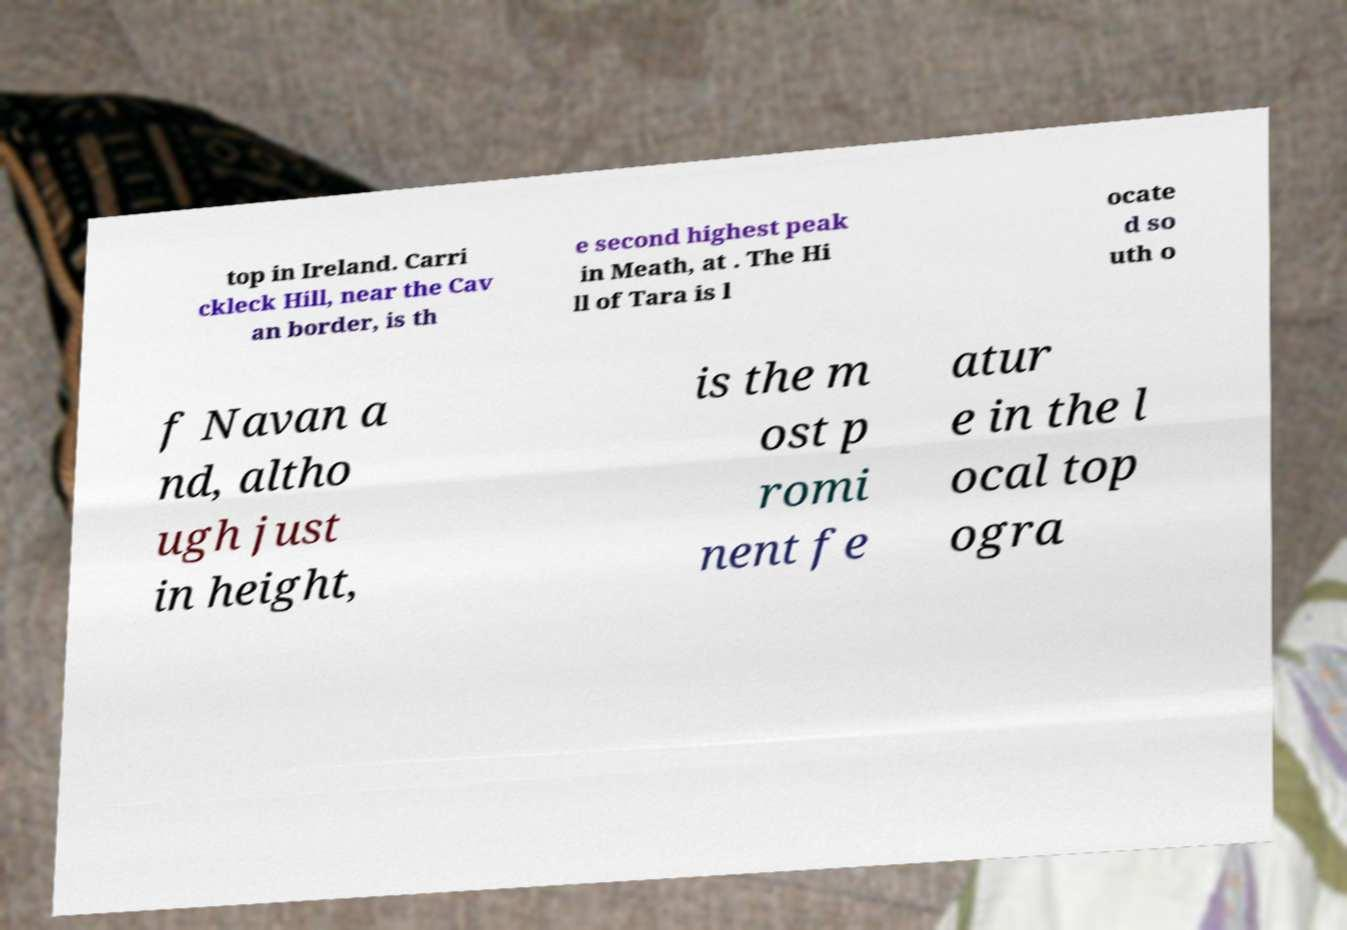Please identify and transcribe the text found in this image. top in Ireland. Carri ckleck Hill, near the Cav an border, is th e second highest peak in Meath, at . The Hi ll of Tara is l ocate d so uth o f Navan a nd, altho ugh just in height, is the m ost p romi nent fe atur e in the l ocal top ogra 